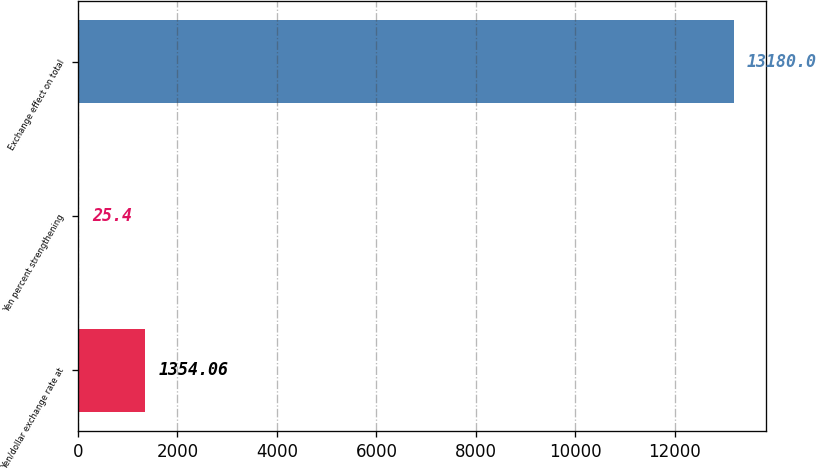<chart> <loc_0><loc_0><loc_500><loc_500><bar_chart><fcel>Yen/dollar exchange rate at<fcel>Yen percent strengthening<fcel>Exchange effect on total<nl><fcel>1354.06<fcel>25.4<fcel>13180<nl></chart> 